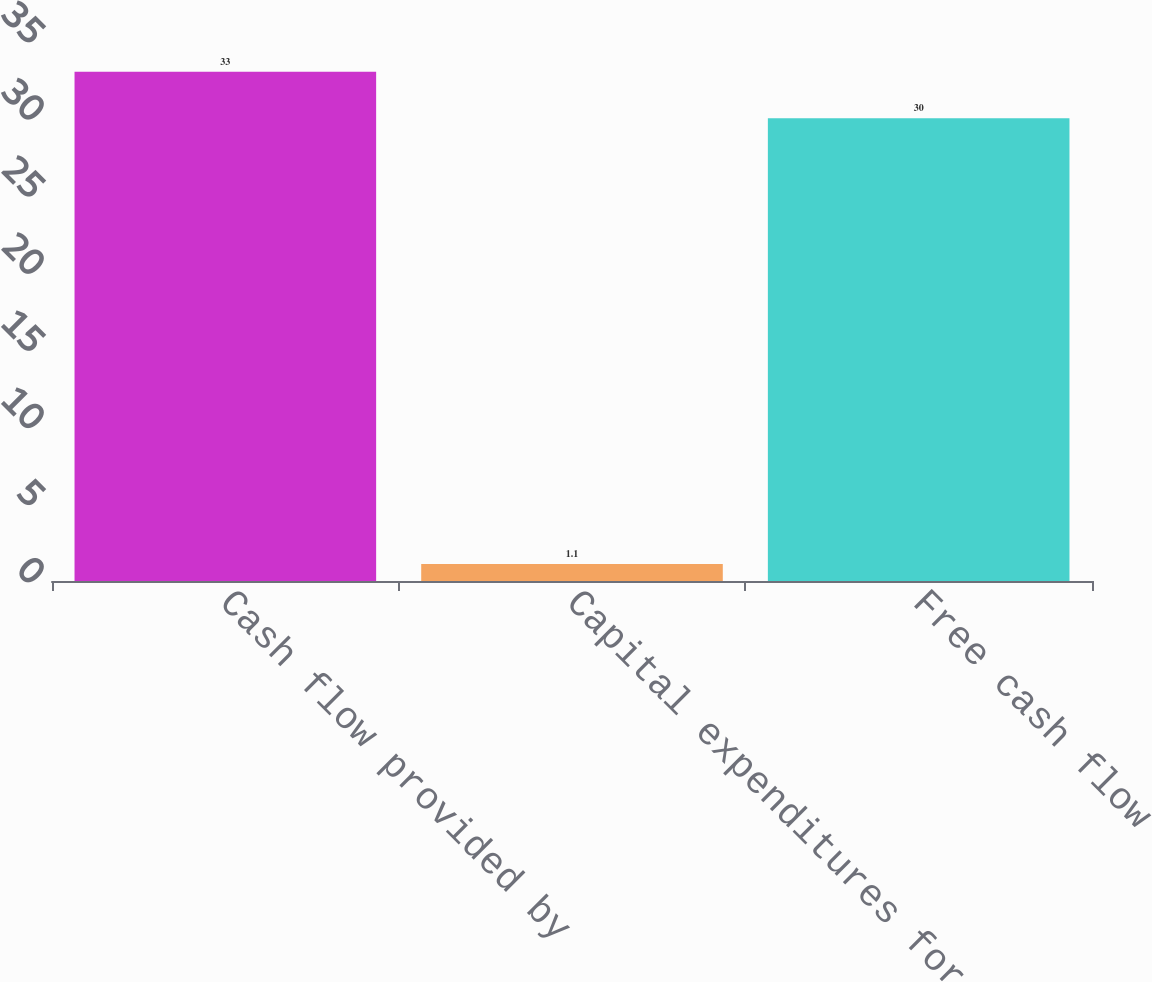<chart> <loc_0><loc_0><loc_500><loc_500><bar_chart><fcel>Cash flow provided by<fcel>Capital expenditures for<fcel>Free cash flow<nl><fcel>33<fcel>1.1<fcel>30<nl></chart> 